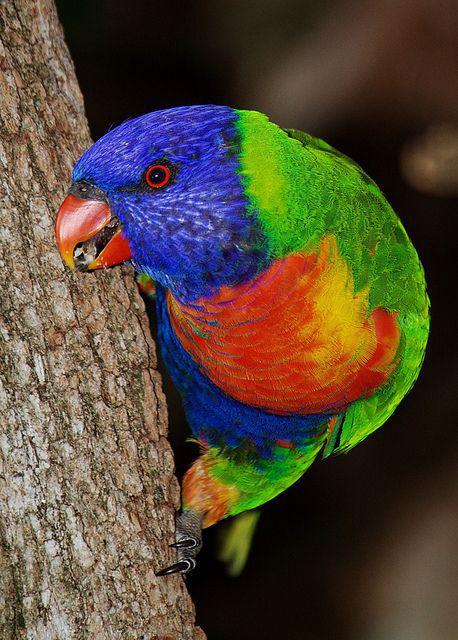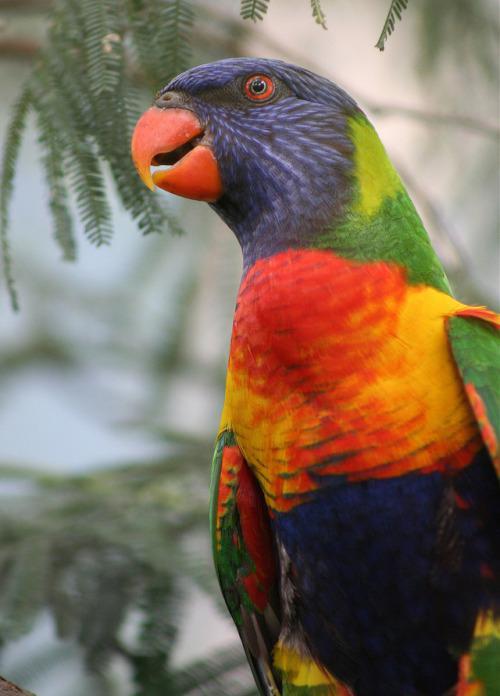The first image is the image on the left, the second image is the image on the right. Assess this claim about the two images: "There are three birds, two in the left image and one on the right.". Correct or not? Answer yes or no. No. The first image is the image on the left, the second image is the image on the right. Considering the images on both sides, is "In at least one of the pictures, there are two birds that are both the same color." valid? Answer yes or no. No. 